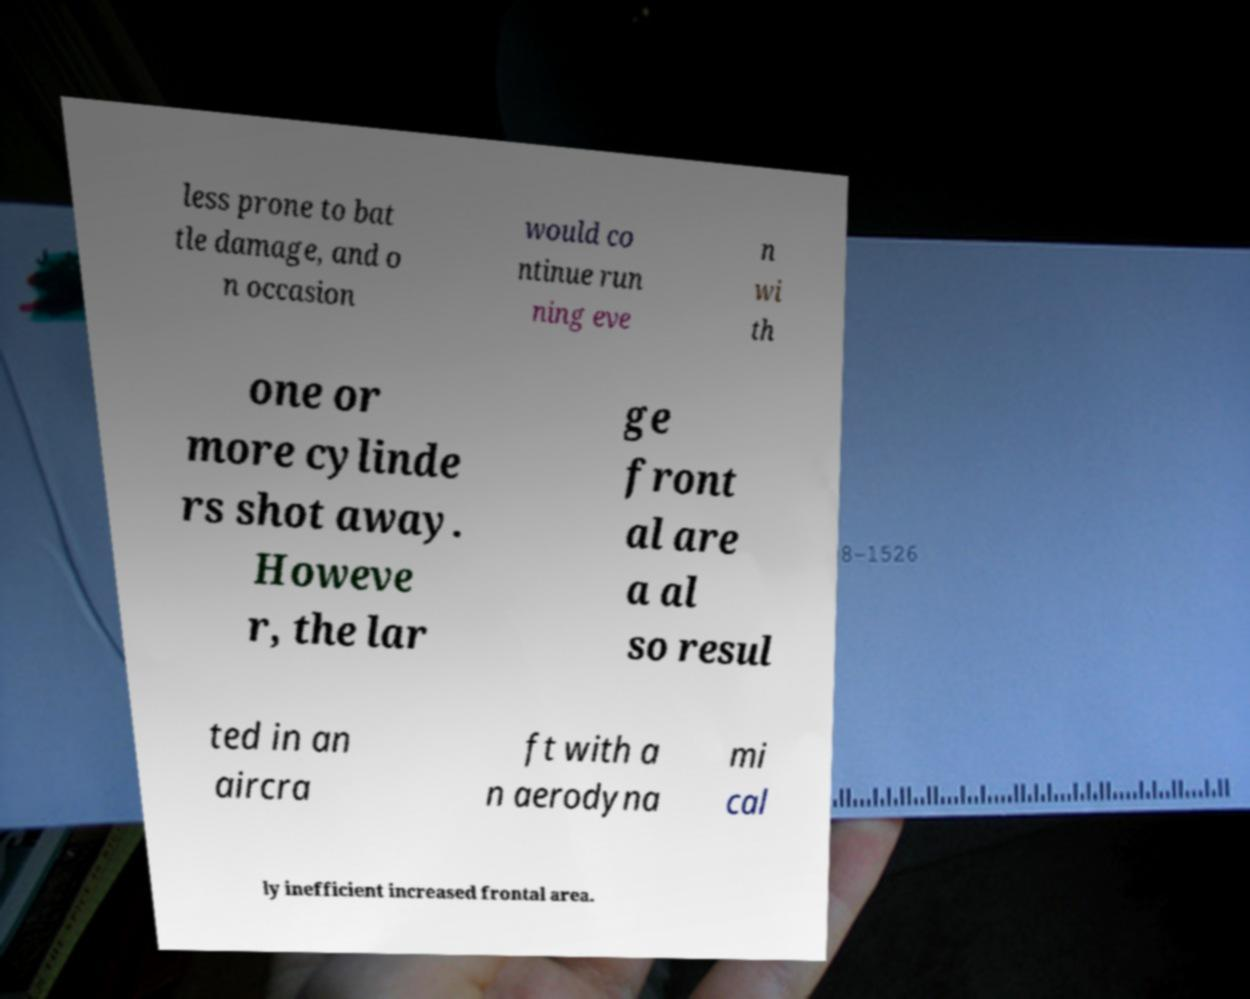Can you accurately transcribe the text from the provided image for me? less prone to bat tle damage, and o n occasion would co ntinue run ning eve n wi th one or more cylinde rs shot away. Howeve r, the lar ge front al are a al so resul ted in an aircra ft with a n aerodyna mi cal ly inefficient increased frontal area. 